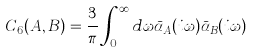<formula> <loc_0><loc_0><loc_500><loc_500>C _ { 6 } ( A , B ) = \frac { 3 } { \pi } \int _ { 0 } ^ { \infty } d \omega \bar { \alpha } _ { A } ( i \omega ) \bar { \alpha } _ { B } ( i \omega )</formula> 